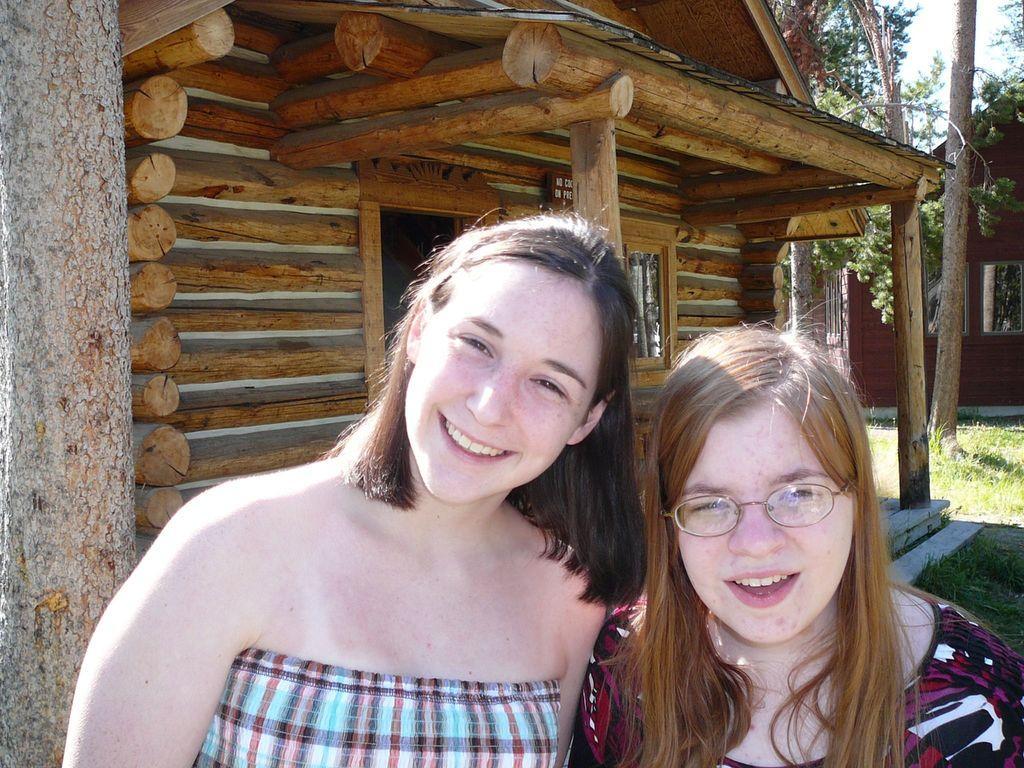In one or two sentences, can you explain what this image depicts? In this given image, We can see a trunk of a tree, There is a small hut which is built with wooden sticks and we can see a few trees towards right and house, grass after, We can see two people standing. 